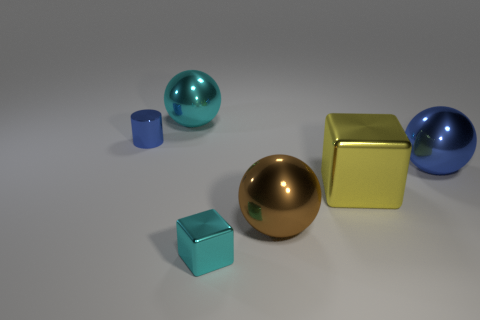There is a blue metallic object to the left of the blue object to the right of the cube on the right side of the cyan cube; what size is it?
Provide a succinct answer. Small. What is the material of the object that is the same color as the small cylinder?
Make the answer very short. Metal. Is there anything else that is the same shape as the small blue metallic object?
Your response must be concise. No. What size is the cyan metallic object in front of the big ball to the left of the large brown metallic sphere?
Offer a terse response. Small. What number of tiny objects are either yellow metallic things or blue shiny blocks?
Offer a terse response. 0. Is the number of large green rubber cylinders less than the number of brown metal spheres?
Provide a short and direct response. Yes. Is the number of large things greater than the number of metal objects?
Your response must be concise. No. What number of other things are the same color as the small metallic cylinder?
Your response must be concise. 1. How many small blue cylinders are on the right side of the brown shiny object that is in front of the small blue metal thing?
Your response must be concise. 0. There is a big cyan shiny thing; are there any large yellow objects on the left side of it?
Provide a succinct answer. No. 